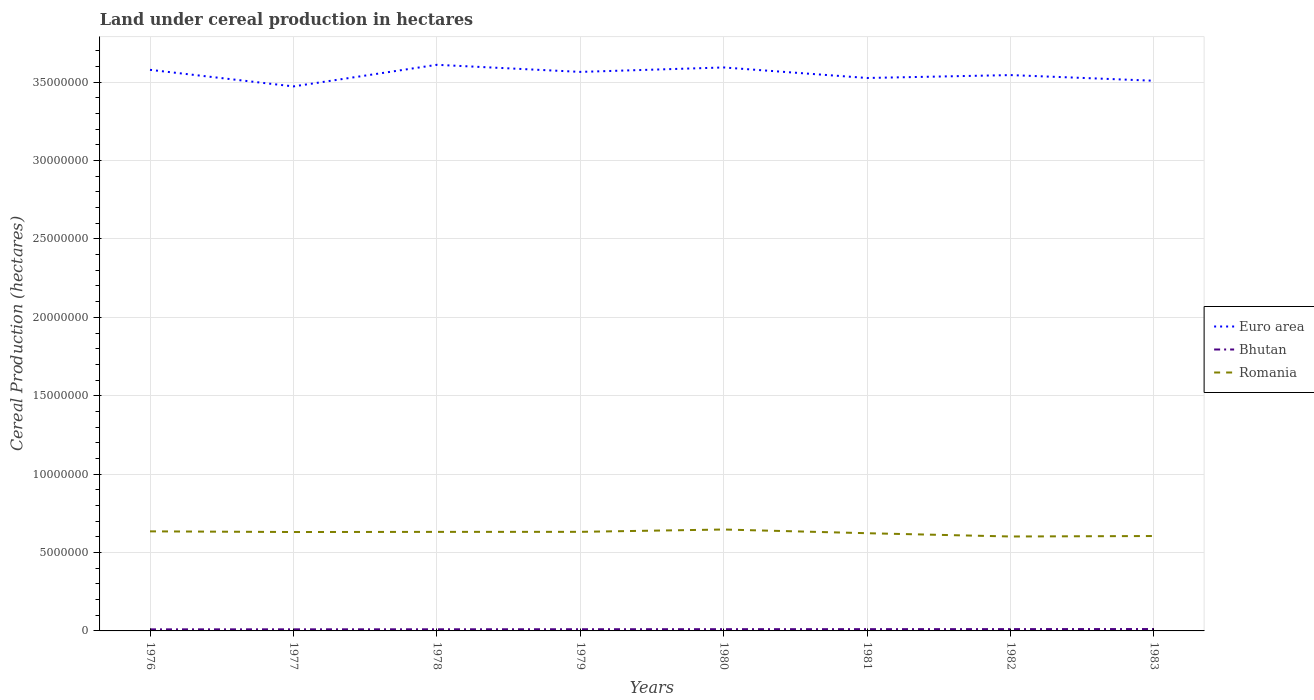How many different coloured lines are there?
Keep it short and to the point. 3. Does the line corresponding to Euro area intersect with the line corresponding to Romania?
Your answer should be compact. No. Across all years, what is the maximum land under cereal production in Bhutan?
Your response must be concise. 9.98e+04. In which year was the land under cereal production in Bhutan maximum?
Make the answer very short. 1976. What is the total land under cereal production in Bhutan in the graph?
Provide a short and direct response. -7650. What is the difference between the highest and the second highest land under cereal production in Bhutan?
Give a very brief answer. 2.04e+04. What is the difference between the highest and the lowest land under cereal production in Euro area?
Provide a succinct answer. 4. Is the land under cereal production in Bhutan strictly greater than the land under cereal production in Romania over the years?
Make the answer very short. Yes. How many lines are there?
Your response must be concise. 3. How many years are there in the graph?
Offer a very short reply. 8. What is the difference between two consecutive major ticks on the Y-axis?
Offer a very short reply. 5.00e+06. Are the values on the major ticks of Y-axis written in scientific E-notation?
Make the answer very short. No. Where does the legend appear in the graph?
Ensure brevity in your answer.  Center right. How many legend labels are there?
Offer a terse response. 3. How are the legend labels stacked?
Your response must be concise. Vertical. What is the title of the graph?
Keep it short and to the point. Land under cereal production in hectares. Does "Chile" appear as one of the legend labels in the graph?
Provide a short and direct response. No. What is the label or title of the Y-axis?
Your response must be concise. Cereal Production (hectares). What is the Cereal Production (hectares) of Euro area in 1976?
Offer a very short reply. 3.58e+07. What is the Cereal Production (hectares) in Bhutan in 1976?
Ensure brevity in your answer.  9.98e+04. What is the Cereal Production (hectares) in Romania in 1976?
Your answer should be compact. 6.35e+06. What is the Cereal Production (hectares) in Euro area in 1977?
Your response must be concise. 3.47e+07. What is the Cereal Production (hectares) in Bhutan in 1977?
Offer a very short reply. 1.02e+05. What is the Cereal Production (hectares) in Romania in 1977?
Make the answer very short. 6.31e+06. What is the Cereal Production (hectares) in Euro area in 1978?
Keep it short and to the point. 3.61e+07. What is the Cereal Production (hectares) of Bhutan in 1978?
Provide a succinct answer. 1.04e+05. What is the Cereal Production (hectares) in Romania in 1978?
Offer a very short reply. 6.32e+06. What is the Cereal Production (hectares) in Euro area in 1979?
Provide a short and direct response. 3.57e+07. What is the Cereal Production (hectares) of Bhutan in 1979?
Ensure brevity in your answer.  1.07e+05. What is the Cereal Production (hectares) of Romania in 1979?
Keep it short and to the point. 6.32e+06. What is the Cereal Production (hectares) of Euro area in 1980?
Provide a succinct answer. 3.59e+07. What is the Cereal Production (hectares) of Bhutan in 1980?
Your response must be concise. 1.11e+05. What is the Cereal Production (hectares) of Romania in 1980?
Offer a terse response. 6.47e+06. What is the Cereal Production (hectares) in Euro area in 1981?
Offer a very short reply. 3.53e+07. What is the Cereal Production (hectares) of Bhutan in 1981?
Keep it short and to the point. 1.12e+05. What is the Cereal Production (hectares) in Romania in 1981?
Provide a short and direct response. 6.23e+06. What is the Cereal Production (hectares) in Euro area in 1982?
Offer a terse response. 3.55e+07. What is the Cereal Production (hectares) of Bhutan in 1982?
Make the answer very short. 1.15e+05. What is the Cereal Production (hectares) of Romania in 1982?
Your answer should be compact. 6.02e+06. What is the Cereal Production (hectares) of Euro area in 1983?
Make the answer very short. 3.51e+07. What is the Cereal Production (hectares) in Bhutan in 1983?
Keep it short and to the point. 1.20e+05. What is the Cereal Production (hectares) of Romania in 1983?
Ensure brevity in your answer.  6.05e+06. Across all years, what is the maximum Cereal Production (hectares) of Euro area?
Make the answer very short. 3.61e+07. Across all years, what is the maximum Cereal Production (hectares) in Bhutan?
Provide a succinct answer. 1.20e+05. Across all years, what is the maximum Cereal Production (hectares) in Romania?
Your response must be concise. 6.47e+06. Across all years, what is the minimum Cereal Production (hectares) of Euro area?
Make the answer very short. 3.47e+07. Across all years, what is the minimum Cereal Production (hectares) of Bhutan?
Offer a very short reply. 9.98e+04. Across all years, what is the minimum Cereal Production (hectares) of Romania?
Keep it short and to the point. 6.02e+06. What is the total Cereal Production (hectares) in Euro area in the graph?
Ensure brevity in your answer.  2.84e+08. What is the total Cereal Production (hectares) of Bhutan in the graph?
Make the answer very short. 8.71e+05. What is the total Cereal Production (hectares) of Romania in the graph?
Your response must be concise. 5.01e+07. What is the difference between the Cereal Production (hectares) of Euro area in 1976 and that in 1977?
Provide a succinct answer. 1.06e+06. What is the difference between the Cereal Production (hectares) of Bhutan in 1976 and that in 1977?
Keep it short and to the point. -1900. What is the difference between the Cereal Production (hectares) in Romania in 1976 and that in 1977?
Your answer should be compact. 4.25e+04. What is the difference between the Cereal Production (hectares) of Euro area in 1976 and that in 1978?
Your response must be concise. -3.21e+05. What is the difference between the Cereal Production (hectares) of Bhutan in 1976 and that in 1978?
Give a very brief answer. -4200. What is the difference between the Cereal Production (hectares) of Romania in 1976 and that in 1978?
Offer a very short reply. 3.31e+04. What is the difference between the Cereal Production (hectares) in Euro area in 1976 and that in 1979?
Provide a short and direct response. 1.32e+05. What is the difference between the Cereal Production (hectares) of Bhutan in 1976 and that in 1979?
Keep it short and to the point. -7650. What is the difference between the Cereal Production (hectares) in Romania in 1976 and that in 1979?
Provide a short and direct response. 3.06e+04. What is the difference between the Cereal Production (hectares) of Euro area in 1976 and that in 1980?
Give a very brief answer. -1.52e+05. What is the difference between the Cereal Production (hectares) in Bhutan in 1976 and that in 1980?
Offer a terse response. -1.12e+04. What is the difference between the Cereal Production (hectares) of Romania in 1976 and that in 1980?
Offer a terse response. -1.18e+05. What is the difference between the Cereal Production (hectares) of Euro area in 1976 and that in 1981?
Give a very brief answer. 5.20e+05. What is the difference between the Cereal Production (hectares) in Bhutan in 1976 and that in 1981?
Your response must be concise. -1.25e+04. What is the difference between the Cereal Production (hectares) in Romania in 1976 and that in 1981?
Your answer should be compact. 1.19e+05. What is the difference between the Cereal Production (hectares) of Euro area in 1976 and that in 1982?
Provide a succinct answer. 3.35e+05. What is the difference between the Cereal Production (hectares) of Bhutan in 1976 and that in 1982?
Your answer should be compact. -1.52e+04. What is the difference between the Cereal Production (hectares) of Romania in 1976 and that in 1982?
Offer a very short reply. 3.28e+05. What is the difference between the Cereal Production (hectares) of Euro area in 1976 and that in 1983?
Your answer should be compact. 6.96e+05. What is the difference between the Cereal Production (hectares) of Bhutan in 1976 and that in 1983?
Ensure brevity in your answer.  -2.04e+04. What is the difference between the Cereal Production (hectares) in Romania in 1976 and that in 1983?
Offer a terse response. 2.98e+05. What is the difference between the Cereal Production (hectares) of Euro area in 1977 and that in 1978?
Offer a terse response. -1.38e+06. What is the difference between the Cereal Production (hectares) of Bhutan in 1977 and that in 1978?
Ensure brevity in your answer.  -2300. What is the difference between the Cereal Production (hectares) in Romania in 1977 and that in 1978?
Provide a short and direct response. -9473. What is the difference between the Cereal Production (hectares) in Euro area in 1977 and that in 1979?
Your answer should be very brief. -9.26e+05. What is the difference between the Cereal Production (hectares) of Bhutan in 1977 and that in 1979?
Offer a terse response. -5750. What is the difference between the Cereal Production (hectares) in Romania in 1977 and that in 1979?
Provide a succinct answer. -1.20e+04. What is the difference between the Cereal Production (hectares) of Euro area in 1977 and that in 1980?
Your answer should be very brief. -1.21e+06. What is the difference between the Cereal Production (hectares) of Bhutan in 1977 and that in 1980?
Provide a short and direct response. -9250. What is the difference between the Cereal Production (hectares) of Romania in 1977 and that in 1980?
Keep it short and to the point. -1.61e+05. What is the difference between the Cereal Production (hectares) in Euro area in 1977 and that in 1981?
Your answer should be very brief. -5.37e+05. What is the difference between the Cereal Production (hectares) of Bhutan in 1977 and that in 1981?
Your response must be concise. -1.06e+04. What is the difference between the Cereal Production (hectares) of Romania in 1977 and that in 1981?
Offer a very short reply. 7.60e+04. What is the difference between the Cereal Production (hectares) in Euro area in 1977 and that in 1982?
Make the answer very short. -7.22e+05. What is the difference between the Cereal Production (hectares) in Bhutan in 1977 and that in 1982?
Provide a succinct answer. -1.33e+04. What is the difference between the Cereal Production (hectares) in Romania in 1977 and that in 1982?
Offer a terse response. 2.85e+05. What is the difference between the Cereal Production (hectares) in Euro area in 1977 and that in 1983?
Ensure brevity in your answer.  -3.61e+05. What is the difference between the Cereal Production (hectares) of Bhutan in 1977 and that in 1983?
Your answer should be compact. -1.84e+04. What is the difference between the Cereal Production (hectares) in Romania in 1977 and that in 1983?
Your answer should be compact. 2.55e+05. What is the difference between the Cereal Production (hectares) of Euro area in 1978 and that in 1979?
Make the answer very short. 4.52e+05. What is the difference between the Cereal Production (hectares) in Bhutan in 1978 and that in 1979?
Your answer should be very brief. -3450. What is the difference between the Cereal Production (hectares) in Romania in 1978 and that in 1979?
Your answer should be very brief. -2480. What is the difference between the Cereal Production (hectares) of Euro area in 1978 and that in 1980?
Keep it short and to the point. 1.69e+05. What is the difference between the Cereal Production (hectares) of Bhutan in 1978 and that in 1980?
Keep it short and to the point. -6950. What is the difference between the Cereal Production (hectares) in Romania in 1978 and that in 1980?
Offer a very short reply. -1.51e+05. What is the difference between the Cereal Production (hectares) of Euro area in 1978 and that in 1981?
Ensure brevity in your answer.  8.41e+05. What is the difference between the Cereal Production (hectares) of Bhutan in 1978 and that in 1981?
Offer a very short reply. -8300. What is the difference between the Cereal Production (hectares) of Romania in 1978 and that in 1981?
Your response must be concise. 8.55e+04. What is the difference between the Cereal Production (hectares) of Euro area in 1978 and that in 1982?
Offer a terse response. 6.56e+05. What is the difference between the Cereal Production (hectares) of Bhutan in 1978 and that in 1982?
Keep it short and to the point. -1.10e+04. What is the difference between the Cereal Production (hectares) in Romania in 1978 and that in 1982?
Ensure brevity in your answer.  2.95e+05. What is the difference between the Cereal Production (hectares) of Euro area in 1978 and that in 1983?
Offer a terse response. 1.02e+06. What is the difference between the Cereal Production (hectares) of Bhutan in 1978 and that in 1983?
Give a very brief answer. -1.62e+04. What is the difference between the Cereal Production (hectares) in Romania in 1978 and that in 1983?
Offer a very short reply. 2.65e+05. What is the difference between the Cereal Production (hectares) of Euro area in 1979 and that in 1980?
Ensure brevity in your answer.  -2.83e+05. What is the difference between the Cereal Production (hectares) of Bhutan in 1979 and that in 1980?
Offer a very short reply. -3500. What is the difference between the Cereal Production (hectares) of Romania in 1979 and that in 1980?
Give a very brief answer. -1.49e+05. What is the difference between the Cereal Production (hectares) in Euro area in 1979 and that in 1981?
Provide a succinct answer. 3.88e+05. What is the difference between the Cereal Production (hectares) in Bhutan in 1979 and that in 1981?
Give a very brief answer. -4850. What is the difference between the Cereal Production (hectares) of Romania in 1979 and that in 1981?
Make the answer very short. 8.80e+04. What is the difference between the Cereal Production (hectares) of Euro area in 1979 and that in 1982?
Provide a succinct answer. 2.03e+05. What is the difference between the Cereal Production (hectares) in Bhutan in 1979 and that in 1982?
Keep it short and to the point. -7567. What is the difference between the Cereal Production (hectares) in Romania in 1979 and that in 1982?
Your answer should be compact. 2.97e+05. What is the difference between the Cereal Production (hectares) in Euro area in 1979 and that in 1983?
Keep it short and to the point. 5.64e+05. What is the difference between the Cereal Production (hectares) of Bhutan in 1979 and that in 1983?
Offer a very short reply. -1.27e+04. What is the difference between the Cereal Production (hectares) in Romania in 1979 and that in 1983?
Offer a very short reply. 2.67e+05. What is the difference between the Cereal Production (hectares) in Euro area in 1980 and that in 1981?
Provide a short and direct response. 6.71e+05. What is the difference between the Cereal Production (hectares) of Bhutan in 1980 and that in 1981?
Provide a short and direct response. -1350. What is the difference between the Cereal Production (hectares) in Romania in 1980 and that in 1981?
Make the answer very short. 2.37e+05. What is the difference between the Cereal Production (hectares) of Euro area in 1980 and that in 1982?
Your answer should be very brief. 4.86e+05. What is the difference between the Cereal Production (hectares) of Bhutan in 1980 and that in 1982?
Your answer should be very brief. -4067. What is the difference between the Cereal Production (hectares) in Romania in 1980 and that in 1982?
Keep it short and to the point. 4.46e+05. What is the difference between the Cereal Production (hectares) in Euro area in 1980 and that in 1983?
Ensure brevity in your answer.  8.47e+05. What is the difference between the Cereal Production (hectares) of Bhutan in 1980 and that in 1983?
Keep it short and to the point. -9200. What is the difference between the Cereal Production (hectares) in Romania in 1980 and that in 1983?
Give a very brief answer. 4.16e+05. What is the difference between the Cereal Production (hectares) in Euro area in 1981 and that in 1982?
Make the answer very short. -1.85e+05. What is the difference between the Cereal Production (hectares) in Bhutan in 1981 and that in 1982?
Make the answer very short. -2717. What is the difference between the Cereal Production (hectares) in Romania in 1981 and that in 1982?
Offer a terse response. 2.09e+05. What is the difference between the Cereal Production (hectares) in Euro area in 1981 and that in 1983?
Provide a succinct answer. 1.76e+05. What is the difference between the Cereal Production (hectares) in Bhutan in 1981 and that in 1983?
Ensure brevity in your answer.  -7850. What is the difference between the Cereal Production (hectares) in Romania in 1981 and that in 1983?
Ensure brevity in your answer.  1.79e+05. What is the difference between the Cereal Production (hectares) of Euro area in 1982 and that in 1983?
Give a very brief answer. 3.61e+05. What is the difference between the Cereal Production (hectares) of Bhutan in 1982 and that in 1983?
Keep it short and to the point. -5133. What is the difference between the Cereal Production (hectares) in Romania in 1982 and that in 1983?
Provide a succinct answer. -3.01e+04. What is the difference between the Cereal Production (hectares) in Euro area in 1976 and the Cereal Production (hectares) in Bhutan in 1977?
Your answer should be compact. 3.57e+07. What is the difference between the Cereal Production (hectares) in Euro area in 1976 and the Cereal Production (hectares) in Romania in 1977?
Offer a terse response. 2.95e+07. What is the difference between the Cereal Production (hectares) of Bhutan in 1976 and the Cereal Production (hectares) of Romania in 1977?
Offer a terse response. -6.21e+06. What is the difference between the Cereal Production (hectares) in Euro area in 1976 and the Cereal Production (hectares) in Bhutan in 1978?
Give a very brief answer. 3.57e+07. What is the difference between the Cereal Production (hectares) in Euro area in 1976 and the Cereal Production (hectares) in Romania in 1978?
Offer a terse response. 2.95e+07. What is the difference between the Cereal Production (hectares) in Bhutan in 1976 and the Cereal Production (hectares) in Romania in 1978?
Your answer should be very brief. -6.22e+06. What is the difference between the Cereal Production (hectares) in Euro area in 1976 and the Cereal Production (hectares) in Bhutan in 1979?
Your answer should be very brief. 3.57e+07. What is the difference between the Cereal Production (hectares) of Euro area in 1976 and the Cereal Production (hectares) of Romania in 1979?
Offer a very short reply. 2.95e+07. What is the difference between the Cereal Production (hectares) of Bhutan in 1976 and the Cereal Production (hectares) of Romania in 1979?
Your response must be concise. -6.22e+06. What is the difference between the Cereal Production (hectares) in Euro area in 1976 and the Cereal Production (hectares) in Bhutan in 1980?
Provide a short and direct response. 3.57e+07. What is the difference between the Cereal Production (hectares) in Euro area in 1976 and the Cereal Production (hectares) in Romania in 1980?
Provide a short and direct response. 2.93e+07. What is the difference between the Cereal Production (hectares) of Bhutan in 1976 and the Cereal Production (hectares) of Romania in 1980?
Your answer should be very brief. -6.37e+06. What is the difference between the Cereal Production (hectares) in Euro area in 1976 and the Cereal Production (hectares) in Bhutan in 1981?
Keep it short and to the point. 3.57e+07. What is the difference between the Cereal Production (hectares) of Euro area in 1976 and the Cereal Production (hectares) of Romania in 1981?
Offer a very short reply. 2.96e+07. What is the difference between the Cereal Production (hectares) in Bhutan in 1976 and the Cereal Production (hectares) in Romania in 1981?
Ensure brevity in your answer.  -6.13e+06. What is the difference between the Cereal Production (hectares) of Euro area in 1976 and the Cereal Production (hectares) of Bhutan in 1982?
Your answer should be compact. 3.57e+07. What is the difference between the Cereal Production (hectares) of Euro area in 1976 and the Cereal Production (hectares) of Romania in 1982?
Provide a short and direct response. 2.98e+07. What is the difference between the Cereal Production (hectares) of Bhutan in 1976 and the Cereal Production (hectares) of Romania in 1982?
Your answer should be very brief. -5.92e+06. What is the difference between the Cereal Production (hectares) of Euro area in 1976 and the Cereal Production (hectares) of Bhutan in 1983?
Your answer should be very brief. 3.57e+07. What is the difference between the Cereal Production (hectares) in Euro area in 1976 and the Cereal Production (hectares) in Romania in 1983?
Keep it short and to the point. 2.97e+07. What is the difference between the Cereal Production (hectares) of Bhutan in 1976 and the Cereal Production (hectares) of Romania in 1983?
Keep it short and to the point. -5.95e+06. What is the difference between the Cereal Production (hectares) of Euro area in 1977 and the Cereal Production (hectares) of Bhutan in 1978?
Provide a short and direct response. 3.46e+07. What is the difference between the Cereal Production (hectares) in Euro area in 1977 and the Cereal Production (hectares) in Romania in 1978?
Provide a short and direct response. 2.84e+07. What is the difference between the Cereal Production (hectares) of Bhutan in 1977 and the Cereal Production (hectares) of Romania in 1978?
Offer a terse response. -6.22e+06. What is the difference between the Cereal Production (hectares) of Euro area in 1977 and the Cereal Production (hectares) of Bhutan in 1979?
Offer a terse response. 3.46e+07. What is the difference between the Cereal Production (hectares) in Euro area in 1977 and the Cereal Production (hectares) in Romania in 1979?
Your response must be concise. 2.84e+07. What is the difference between the Cereal Production (hectares) of Bhutan in 1977 and the Cereal Production (hectares) of Romania in 1979?
Your response must be concise. -6.22e+06. What is the difference between the Cereal Production (hectares) in Euro area in 1977 and the Cereal Production (hectares) in Bhutan in 1980?
Provide a short and direct response. 3.46e+07. What is the difference between the Cereal Production (hectares) in Euro area in 1977 and the Cereal Production (hectares) in Romania in 1980?
Your response must be concise. 2.83e+07. What is the difference between the Cereal Production (hectares) in Bhutan in 1977 and the Cereal Production (hectares) in Romania in 1980?
Offer a terse response. -6.37e+06. What is the difference between the Cereal Production (hectares) in Euro area in 1977 and the Cereal Production (hectares) in Bhutan in 1981?
Your answer should be very brief. 3.46e+07. What is the difference between the Cereal Production (hectares) of Euro area in 1977 and the Cereal Production (hectares) of Romania in 1981?
Offer a very short reply. 2.85e+07. What is the difference between the Cereal Production (hectares) in Bhutan in 1977 and the Cereal Production (hectares) in Romania in 1981?
Ensure brevity in your answer.  -6.13e+06. What is the difference between the Cereal Production (hectares) in Euro area in 1977 and the Cereal Production (hectares) in Bhutan in 1982?
Your response must be concise. 3.46e+07. What is the difference between the Cereal Production (hectares) of Euro area in 1977 and the Cereal Production (hectares) of Romania in 1982?
Provide a succinct answer. 2.87e+07. What is the difference between the Cereal Production (hectares) of Bhutan in 1977 and the Cereal Production (hectares) of Romania in 1982?
Make the answer very short. -5.92e+06. What is the difference between the Cereal Production (hectares) of Euro area in 1977 and the Cereal Production (hectares) of Bhutan in 1983?
Your answer should be very brief. 3.46e+07. What is the difference between the Cereal Production (hectares) of Euro area in 1977 and the Cereal Production (hectares) of Romania in 1983?
Make the answer very short. 2.87e+07. What is the difference between the Cereal Production (hectares) in Bhutan in 1977 and the Cereal Production (hectares) in Romania in 1983?
Your answer should be compact. -5.95e+06. What is the difference between the Cereal Production (hectares) in Euro area in 1978 and the Cereal Production (hectares) in Bhutan in 1979?
Ensure brevity in your answer.  3.60e+07. What is the difference between the Cereal Production (hectares) in Euro area in 1978 and the Cereal Production (hectares) in Romania in 1979?
Offer a terse response. 2.98e+07. What is the difference between the Cereal Production (hectares) in Bhutan in 1978 and the Cereal Production (hectares) in Romania in 1979?
Offer a terse response. -6.22e+06. What is the difference between the Cereal Production (hectares) of Euro area in 1978 and the Cereal Production (hectares) of Bhutan in 1980?
Ensure brevity in your answer.  3.60e+07. What is the difference between the Cereal Production (hectares) in Euro area in 1978 and the Cereal Production (hectares) in Romania in 1980?
Offer a terse response. 2.96e+07. What is the difference between the Cereal Production (hectares) of Bhutan in 1978 and the Cereal Production (hectares) of Romania in 1980?
Your answer should be compact. -6.36e+06. What is the difference between the Cereal Production (hectares) of Euro area in 1978 and the Cereal Production (hectares) of Bhutan in 1981?
Your answer should be very brief. 3.60e+07. What is the difference between the Cereal Production (hectares) in Euro area in 1978 and the Cereal Production (hectares) in Romania in 1981?
Offer a very short reply. 2.99e+07. What is the difference between the Cereal Production (hectares) in Bhutan in 1978 and the Cereal Production (hectares) in Romania in 1981?
Your answer should be compact. -6.13e+06. What is the difference between the Cereal Production (hectares) in Euro area in 1978 and the Cereal Production (hectares) in Bhutan in 1982?
Offer a terse response. 3.60e+07. What is the difference between the Cereal Production (hectares) of Euro area in 1978 and the Cereal Production (hectares) of Romania in 1982?
Your answer should be compact. 3.01e+07. What is the difference between the Cereal Production (hectares) of Bhutan in 1978 and the Cereal Production (hectares) of Romania in 1982?
Provide a succinct answer. -5.92e+06. What is the difference between the Cereal Production (hectares) of Euro area in 1978 and the Cereal Production (hectares) of Bhutan in 1983?
Offer a terse response. 3.60e+07. What is the difference between the Cereal Production (hectares) in Euro area in 1978 and the Cereal Production (hectares) in Romania in 1983?
Keep it short and to the point. 3.01e+07. What is the difference between the Cereal Production (hectares) in Bhutan in 1978 and the Cereal Production (hectares) in Romania in 1983?
Make the answer very short. -5.95e+06. What is the difference between the Cereal Production (hectares) of Euro area in 1979 and the Cereal Production (hectares) of Bhutan in 1980?
Offer a very short reply. 3.55e+07. What is the difference between the Cereal Production (hectares) in Euro area in 1979 and the Cereal Production (hectares) in Romania in 1980?
Your answer should be very brief. 2.92e+07. What is the difference between the Cereal Production (hectares) in Bhutan in 1979 and the Cereal Production (hectares) in Romania in 1980?
Offer a terse response. -6.36e+06. What is the difference between the Cereal Production (hectares) of Euro area in 1979 and the Cereal Production (hectares) of Bhutan in 1981?
Make the answer very short. 3.55e+07. What is the difference between the Cereal Production (hectares) of Euro area in 1979 and the Cereal Production (hectares) of Romania in 1981?
Offer a very short reply. 2.94e+07. What is the difference between the Cereal Production (hectares) in Bhutan in 1979 and the Cereal Production (hectares) in Romania in 1981?
Give a very brief answer. -6.12e+06. What is the difference between the Cereal Production (hectares) of Euro area in 1979 and the Cereal Production (hectares) of Bhutan in 1982?
Make the answer very short. 3.55e+07. What is the difference between the Cereal Production (hectares) in Euro area in 1979 and the Cereal Production (hectares) in Romania in 1982?
Your answer should be compact. 2.96e+07. What is the difference between the Cereal Production (hectares) of Bhutan in 1979 and the Cereal Production (hectares) of Romania in 1982?
Offer a very short reply. -5.92e+06. What is the difference between the Cereal Production (hectares) of Euro area in 1979 and the Cereal Production (hectares) of Bhutan in 1983?
Make the answer very short. 3.55e+07. What is the difference between the Cereal Production (hectares) in Euro area in 1979 and the Cereal Production (hectares) in Romania in 1983?
Keep it short and to the point. 2.96e+07. What is the difference between the Cereal Production (hectares) of Bhutan in 1979 and the Cereal Production (hectares) of Romania in 1983?
Provide a short and direct response. -5.95e+06. What is the difference between the Cereal Production (hectares) in Euro area in 1980 and the Cereal Production (hectares) in Bhutan in 1981?
Make the answer very short. 3.58e+07. What is the difference between the Cereal Production (hectares) of Euro area in 1980 and the Cereal Production (hectares) of Romania in 1981?
Ensure brevity in your answer.  2.97e+07. What is the difference between the Cereal Production (hectares) in Bhutan in 1980 and the Cereal Production (hectares) in Romania in 1981?
Provide a short and direct response. -6.12e+06. What is the difference between the Cereal Production (hectares) of Euro area in 1980 and the Cereal Production (hectares) of Bhutan in 1982?
Provide a short and direct response. 3.58e+07. What is the difference between the Cereal Production (hectares) in Euro area in 1980 and the Cereal Production (hectares) in Romania in 1982?
Ensure brevity in your answer.  2.99e+07. What is the difference between the Cereal Production (hectares) in Bhutan in 1980 and the Cereal Production (hectares) in Romania in 1982?
Provide a short and direct response. -5.91e+06. What is the difference between the Cereal Production (hectares) of Euro area in 1980 and the Cereal Production (hectares) of Bhutan in 1983?
Your response must be concise. 3.58e+07. What is the difference between the Cereal Production (hectares) of Euro area in 1980 and the Cereal Production (hectares) of Romania in 1983?
Give a very brief answer. 2.99e+07. What is the difference between the Cereal Production (hectares) of Bhutan in 1980 and the Cereal Production (hectares) of Romania in 1983?
Provide a succinct answer. -5.94e+06. What is the difference between the Cereal Production (hectares) in Euro area in 1981 and the Cereal Production (hectares) in Bhutan in 1982?
Keep it short and to the point. 3.52e+07. What is the difference between the Cereal Production (hectares) in Euro area in 1981 and the Cereal Production (hectares) in Romania in 1982?
Provide a short and direct response. 2.92e+07. What is the difference between the Cereal Production (hectares) in Bhutan in 1981 and the Cereal Production (hectares) in Romania in 1982?
Ensure brevity in your answer.  -5.91e+06. What is the difference between the Cereal Production (hectares) in Euro area in 1981 and the Cereal Production (hectares) in Bhutan in 1983?
Offer a very short reply. 3.51e+07. What is the difference between the Cereal Production (hectares) in Euro area in 1981 and the Cereal Production (hectares) in Romania in 1983?
Offer a terse response. 2.92e+07. What is the difference between the Cereal Production (hectares) in Bhutan in 1981 and the Cereal Production (hectares) in Romania in 1983?
Offer a terse response. -5.94e+06. What is the difference between the Cereal Production (hectares) in Euro area in 1982 and the Cereal Production (hectares) in Bhutan in 1983?
Your answer should be compact. 3.53e+07. What is the difference between the Cereal Production (hectares) of Euro area in 1982 and the Cereal Production (hectares) of Romania in 1983?
Give a very brief answer. 2.94e+07. What is the difference between the Cereal Production (hectares) of Bhutan in 1982 and the Cereal Production (hectares) of Romania in 1983?
Provide a short and direct response. -5.94e+06. What is the average Cereal Production (hectares) in Euro area per year?
Your response must be concise. 3.55e+07. What is the average Cereal Production (hectares) in Bhutan per year?
Your answer should be compact. 1.09e+05. What is the average Cereal Production (hectares) of Romania per year?
Your answer should be very brief. 6.26e+06. In the year 1976, what is the difference between the Cereal Production (hectares) in Euro area and Cereal Production (hectares) in Bhutan?
Your answer should be very brief. 3.57e+07. In the year 1976, what is the difference between the Cereal Production (hectares) of Euro area and Cereal Production (hectares) of Romania?
Provide a short and direct response. 2.94e+07. In the year 1976, what is the difference between the Cereal Production (hectares) of Bhutan and Cereal Production (hectares) of Romania?
Keep it short and to the point. -6.25e+06. In the year 1977, what is the difference between the Cereal Production (hectares) in Euro area and Cereal Production (hectares) in Bhutan?
Give a very brief answer. 3.46e+07. In the year 1977, what is the difference between the Cereal Production (hectares) in Euro area and Cereal Production (hectares) in Romania?
Offer a terse response. 2.84e+07. In the year 1977, what is the difference between the Cereal Production (hectares) in Bhutan and Cereal Production (hectares) in Romania?
Ensure brevity in your answer.  -6.21e+06. In the year 1978, what is the difference between the Cereal Production (hectares) in Euro area and Cereal Production (hectares) in Bhutan?
Offer a terse response. 3.60e+07. In the year 1978, what is the difference between the Cereal Production (hectares) of Euro area and Cereal Production (hectares) of Romania?
Make the answer very short. 2.98e+07. In the year 1978, what is the difference between the Cereal Production (hectares) in Bhutan and Cereal Production (hectares) in Romania?
Your answer should be compact. -6.21e+06. In the year 1979, what is the difference between the Cereal Production (hectares) in Euro area and Cereal Production (hectares) in Bhutan?
Provide a short and direct response. 3.55e+07. In the year 1979, what is the difference between the Cereal Production (hectares) of Euro area and Cereal Production (hectares) of Romania?
Your answer should be very brief. 2.93e+07. In the year 1979, what is the difference between the Cereal Production (hectares) in Bhutan and Cereal Production (hectares) in Romania?
Provide a short and direct response. -6.21e+06. In the year 1980, what is the difference between the Cereal Production (hectares) of Euro area and Cereal Production (hectares) of Bhutan?
Offer a very short reply. 3.58e+07. In the year 1980, what is the difference between the Cereal Production (hectares) in Euro area and Cereal Production (hectares) in Romania?
Your answer should be very brief. 2.95e+07. In the year 1980, what is the difference between the Cereal Production (hectares) of Bhutan and Cereal Production (hectares) of Romania?
Your response must be concise. -6.36e+06. In the year 1981, what is the difference between the Cereal Production (hectares) of Euro area and Cereal Production (hectares) of Bhutan?
Provide a succinct answer. 3.52e+07. In the year 1981, what is the difference between the Cereal Production (hectares) of Euro area and Cereal Production (hectares) of Romania?
Your response must be concise. 2.90e+07. In the year 1981, what is the difference between the Cereal Production (hectares) of Bhutan and Cereal Production (hectares) of Romania?
Your response must be concise. -6.12e+06. In the year 1982, what is the difference between the Cereal Production (hectares) of Euro area and Cereal Production (hectares) of Bhutan?
Your response must be concise. 3.53e+07. In the year 1982, what is the difference between the Cereal Production (hectares) of Euro area and Cereal Production (hectares) of Romania?
Your answer should be compact. 2.94e+07. In the year 1982, what is the difference between the Cereal Production (hectares) of Bhutan and Cereal Production (hectares) of Romania?
Offer a very short reply. -5.91e+06. In the year 1983, what is the difference between the Cereal Production (hectares) of Euro area and Cereal Production (hectares) of Bhutan?
Your response must be concise. 3.50e+07. In the year 1983, what is the difference between the Cereal Production (hectares) of Euro area and Cereal Production (hectares) of Romania?
Ensure brevity in your answer.  2.90e+07. In the year 1983, what is the difference between the Cereal Production (hectares) in Bhutan and Cereal Production (hectares) in Romania?
Provide a short and direct response. -5.93e+06. What is the ratio of the Cereal Production (hectares) of Euro area in 1976 to that in 1977?
Give a very brief answer. 1.03. What is the ratio of the Cereal Production (hectares) in Bhutan in 1976 to that in 1977?
Offer a very short reply. 0.98. What is the ratio of the Cereal Production (hectares) in Romania in 1976 to that in 1977?
Keep it short and to the point. 1.01. What is the ratio of the Cereal Production (hectares) of Bhutan in 1976 to that in 1978?
Your answer should be compact. 0.96. What is the ratio of the Cereal Production (hectares) of Bhutan in 1976 to that in 1979?
Provide a succinct answer. 0.93. What is the ratio of the Cereal Production (hectares) of Bhutan in 1976 to that in 1980?
Keep it short and to the point. 0.9. What is the ratio of the Cereal Production (hectares) of Romania in 1976 to that in 1980?
Give a very brief answer. 0.98. What is the ratio of the Cereal Production (hectares) of Euro area in 1976 to that in 1981?
Make the answer very short. 1.01. What is the ratio of the Cereal Production (hectares) in Bhutan in 1976 to that in 1981?
Your answer should be compact. 0.89. What is the ratio of the Cereal Production (hectares) of Euro area in 1976 to that in 1982?
Make the answer very short. 1.01. What is the ratio of the Cereal Production (hectares) of Bhutan in 1976 to that in 1982?
Keep it short and to the point. 0.87. What is the ratio of the Cereal Production (hectares) in Romania in 1976 to that in 1982?
Provide a succinct answer. 1.05. What is the ratio of the Cereal Production (hectares) in Euro area in 1976 to that in 1983?
Make the answer very short. 1.02. What is the ratio of the Cereal Production (hectares) of Bhutan in 1976 to that in 1983?
Provide a short and direct response. 0.83. What is the ratio of the Cereal Production (hectares) of Romania in 1976 to that in 1983?
Ensure brevity in your answer.  1.05. What is the ratio of the Cereal Production (hectares) in Euro area in 1977 to that in 1978?
Offer a terse response. 0.96. What is the ratio of the Cereal Production (hectares) in Bhutan in 1977 to that in 1978?
Your answer should be compact. 0.98. What is the ratio of the Cereal Production (hectares) in Bhutan in 1977 to that in 1979?
Give a very brief answer. 0.95. What is the ratio of the Cereal Production (hectares) of Romania in 1977 to that in 1979?
Provide a succinct answer. 1. What is the ratio of the Cereal Production (hectares) of Euro area in 1977 to that in 1980?
Your response must be concise. 0.97. What is the ratio of the Cereal Production (hectares) in Bhutan in 1977 to that in 1980?
Keep it short and to the point. 0.92. What is the ratio of the Cereal Production (hectares) in Romania in 1977 to that in 1980?
Your answer should be very brief. 0.98. What is the ratio of the Cereal Production (hectares) of Euro area in 1977 to that in 1981?
Your answer should be compact. 0.98. What is the ratio of the Cereal Production (hectares) in Bhutan in 1977 to that in 1981?
Your answer should be compact. 0.91. What is the ratio of the Cereal Production (hectares) in Romania in 1977 to that in 1981?
Offer a terse response. 1.01. What is the ratio of the Cereal Production (hectares) of Euro area in 1977 to that in 1982?
Ensure brevity in your answer.  0.98. What is the ratio of the Cereal Production (hectares) of Bhutan in 1977 to that in 1982?
Offer a very short reply. 0.88. What is the ratio of the Cereal Production (hectares) of Romania in 1977 to that in 1982?
Keep it short and to the point. 1.05. What is the ratio of the Cereal Production (hectares) of Bhutan in 1977 to that in 1983?
Offer a terse response. 0.85. What is the ratio of the Cereal Production (hectares) in Romania in 1977 to that in 1983?
Keep it short and to the point. 1.04. What is the ratio of the Cereal Production (hectares) of Euro area in 1978 to that in 1979?
Provide a short and direct response. 1.01. What is the ratio of the Cereal Production (hectares) of Bhutan in 1978 to that in 1979?
Provide a succinct answer. 0.97. What is the ratio of the Cereal Production (hectares) of Romania in 1978 to that in 1979?
Make the answer very short. 1. What is the ratio of the Cereal Production (hectares) in Euro area in 1978 to that in 1980?
Provide a succinct answer. 1. What is the ratio of the Cereal Production (hectares) of Bhutan in 1978 to that in 1980?
Your response must be concise. 0.94. What is the ratio of the Cereal Production (hectares) in Romania in 1978 to that in 1980?
Your response must be concise. 0.98. What is the ratio of the Cereal Production (hectares) of Euro area in 1978 to that in 1981?
Your answer should be very brief. 1.02. What is the ratio of the Cereal Production (hectares) of Bhutan in 1978 to that in 1981?
Keep it short and to the point. 0.93. What is the ratio of the Cereal Production (hectares) of Romania in 1978 to that in 1981?
Your answer should be compact. 1.01. What is the ratio of the Cereal Production (hectares) of Euro area in 1978 to that in 1982?
Keep it short and to the point. 1.02. What is the ratio of the Cereal Production (hectares) of Bhutan in 1978 to that in 1982?
Provide a short and direct response. 0.9. What is the ratio of the Cereal Production (hectares) in Romania in 1978 to that in 1982?
Give a very brief answer. 1.05. What is the ratio of the Cereal Production (hectares) of Bhutan in 1978 to that in 1983?
Your response must be concise. 0.87. What is the ratio of the Cereal Production (hectares) of Romania in 1978 to that in 1983?
Provide a succinct answer. 1.04. What is the ratio of the Cereal Production (hectares) in Bhutan in 1979 to that in 1980?
Make the answer very short. 0.97. What is the ratio of the Cereal Production (hectares) in Bhutan in 1979 to that in 1981?
Ensure brevity in your answer.  0.96. What is the ratio of the Cereal Production (hectares) of Romania in 1979 to that in 1981?
Make the answer very short. 1.01. What is the ratio of the Cereal Production (hectares) of Euro area in 1979 to that in 1982?
Offer a terse response. 1.01. What is the ratio of the Cereal Production (hectares) in Bhutan in 1979 to that in 1982?
Keep it short and to the point. 0.93. What is the ratio of the Cereal Production (hectares) of Romania in 1979 to that in 1982?
Give a very brief answer. 1.05. What is the ratio of the Cereal Production (hectares) in Euro area in 1979 to that in 1983?
Keep it short and to the point. 1.02. What is the ratio of the Cereal Production (hectares) of Bhutan in 1979 to that in 1983?
Offer a very short reply. 0.89. What is the ratio of the Cereal Production (hectares) of Romania in 1979 to that in 1983?
Ensure brevity in your answer.  1.04. What is the ratio of the Cereal Production (hectares) of Romania in 1980 to that in 1981?
Your answer should be compact. 1.04. What is the ratio of the Cereal Production (hectares) of Euro area in 1980 to that in 1982?
Your response must be concise. 1.01. What is the ratio of the Cereal Production (hectares) in Bhutan in 1980 to that in 1982?
Offer a very short reply. 0.96. What is the ratio of the Cereal Production (hectares) of Romania in 1980 to that in 1982?
Give a very brief answer. 1.07. What is the ratio of the Cereal Production (hectares) in Euro area in 1980 to that in 1983?
Make the answer very short. 1.02. What is the ratio of the Cereal Production (hectares) of Bhutan in 1980 to that in 1983?
Make the answer very short. 0.92. What is the ratio of the Cereal Production (hectares) in Romania in 1980 to that in 1983?
Make the answer very short. 1.07. What is the ratio of the Cereal Production (hectares) in Euro area in 1981 to that in 1982?
Provide a succinct answer. 0.99. What is the ratio of the Cereal Production (hectares) of Bhutan in 1981 to that in 1982?
Keep it short and to the point. 0.98. What is the ratio of the Cereal Production (hectares) in Romania in 1981 to that in 1982?
Your answer should be very brief. 1.03. What is the ratio of the Cereal Production (hectares) of Bhutan in 1981 to that in 1983?
Provide a short and direct response. 0.93. What is the ratio of the Cereal Production (hectares) of Romania in 1981 to that in 1983?
Provide a short and direct response. 1.03. What is the ratio of the Cereal Production (hectares) in Euro area in 1982 to that in 1983?
Offer a very short reply. 1.01. What is the ratio of the Cereal Production (hectares) of Bhutan in 1982 to that in 1983?
Keep it short and to the point. 0.96. What is the ratio of the Cereal Production (hectares) in Romania in 1982 to that in 1983?
Provide a succinct answer. 0.99. What is the difference between the highest and the second highest Cereal Production (hectares) of Euro area?
Your response must be concise. 1.69e+05. What is the difference between the highest and the second highest Cereal Production (hectares) of Bhutan?
Your answer should be very brief. 5133. What is the difference between the highest and the second highest Cereal Production (hectares) of Romania?
Your answer should be very brief. 1.18e+05. What is the difference between the highest and the lowest Cereal Production (hectares) of Euro area?
Your response must be concise. 1.38e+06. What is the difference between the highest and the lowest Cereal Production (hectares) in Bhutan?
Your response must be concise. 2.04e+04. What is the difference between the highest and the lowest Cereal Production (hectares) of Romania?
Your answer should be compact. 4.46e+05. 